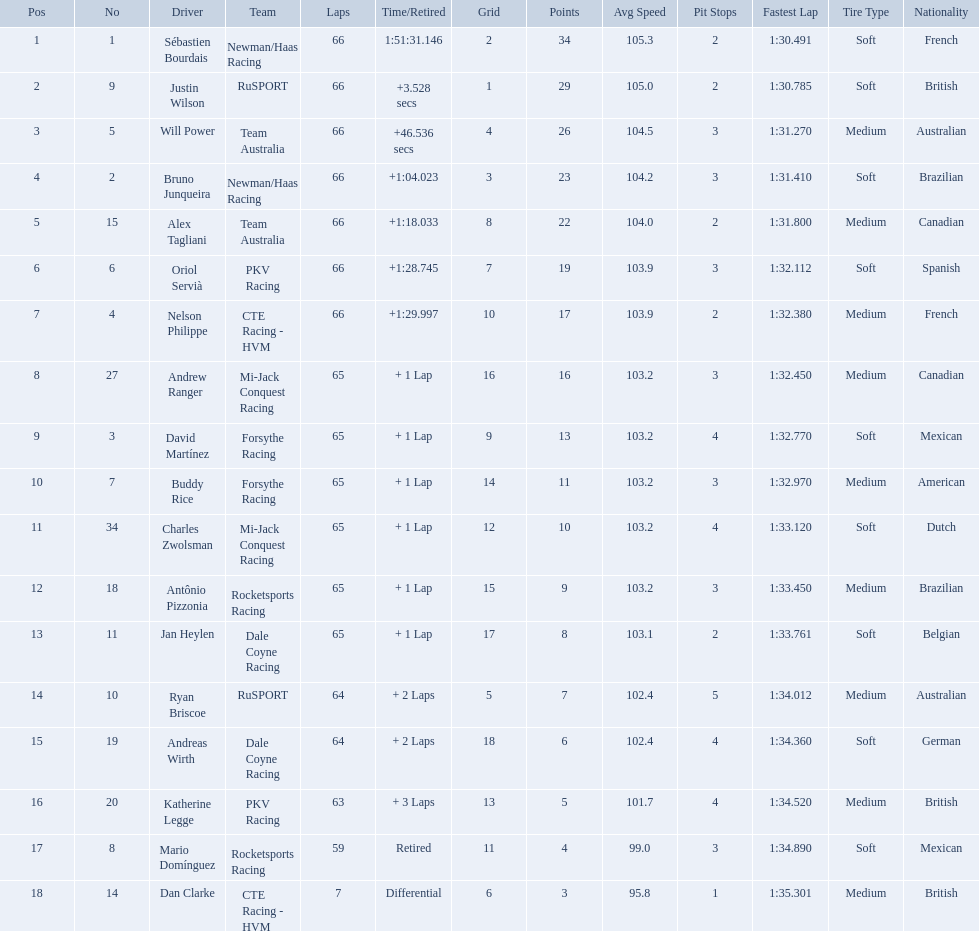How many drivers did not make more than 60 laps? 2. 